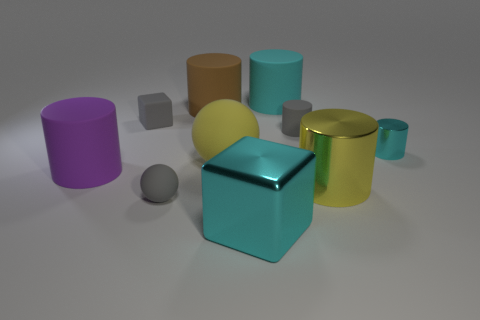How many other objects are the same color as the rubber cube?
Your answer should be very brief. 2. There is a gray rubber sphere; is it the same size as the shiny cylinder behind the large yellow rubber object?
Make the answer very short. Yes. Does the block that is to the left of the brown cylinder have the same size as the big cyan block?
Give a very brief answer. No. What number of other objects are the same material as the large brown cylinder?
Offer a very short reply. 6. Are there an equal number of metal cylinders left of the big purple matte thing and small matte things that are behind the gray ball?
Give a very brief answer. No. There is a cube that is behind the cylinder in front of the rubber cylinder that is on the left side of the small rubber ball; what color is it?
Offer a terse response. Gray. There is a cyan thing behind the brown cylinder; what shape is it?
Your response must be concise. Cylinder. There is a cyan object that is made of the same material as the large cube; what is its shape?
Make the answer very short. Cylinder. What number of big rubber cylinders are behind the yellow rubber object?
Provide a succinct answer. 2. Are there an equal number of metallic cubes to the left of the cyan cube and large gray matte blocks?
Offer a very short reply. Yes. 